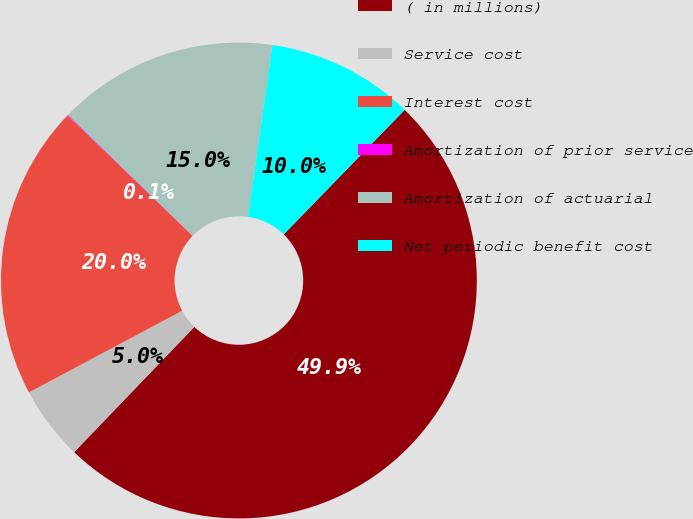Convert chart. <chart><loc_0><loc_0><loc_500><loc_500><pie_chart><fcel>( in millions)<fcel>Service cost<fcel>Interest cost<fcel>Amortization of prior service<fcel>Amortization of actuarial<fcel>Net periodic benefit cost<nl><fcel>49.9%<fcel>5.03%<fcel>19.99%<fcel>0.05%<fcel>15.0%<fcel>10.02%<nl></chart> 